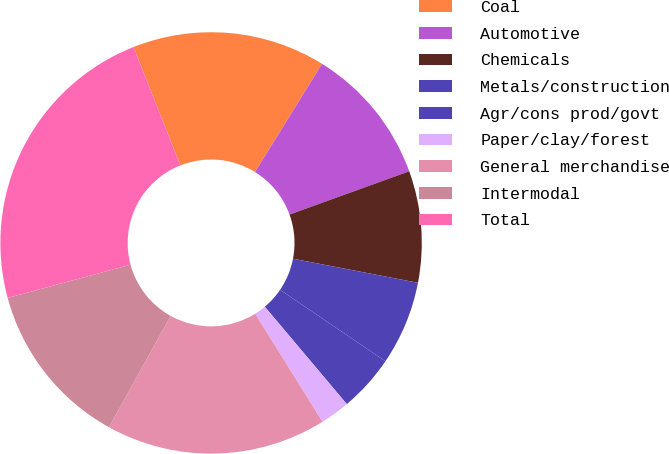<chart> <loc_0><loc_0><loc_500><loc_500><pie_chart><fcel>Coal<fcel>Automotive<fcel>Chemicals<fcel>Metals/construction<fcel>Agr/cons prod/govt<fcel>Paper/clay/forest<fcel>General merchandise<fcel>Intermodal<fcel>Total<nl><fcel>14.83%<fcel>10.65%<fcel>8.55%<fcel>6.46%<fcel>4.37%<fcel>2.27%<fcel>16.92%<fcel>12.74%<fcel>23.2%<nl></chart> 